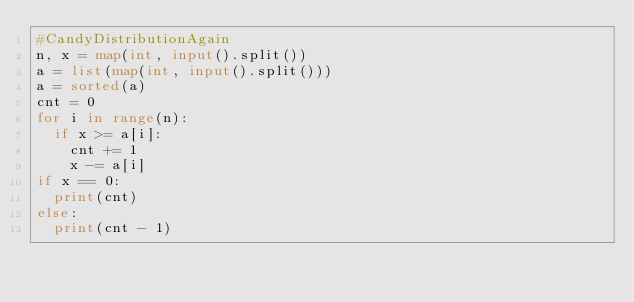<code> <loc_0><loc_0><loc_500><loc_500><_Python_>#CandyDistributionAgain
n, x = map(int, input().split())
a = list(map(int, input().split()))
a = sorted(a)
cnt = 0
for i in range(n):
  if x >= a[i]:
    cnt += 1
    x -= a[i]
if x == 0:
  print(cnt)
else:
  print(cnt - 1)</code> 